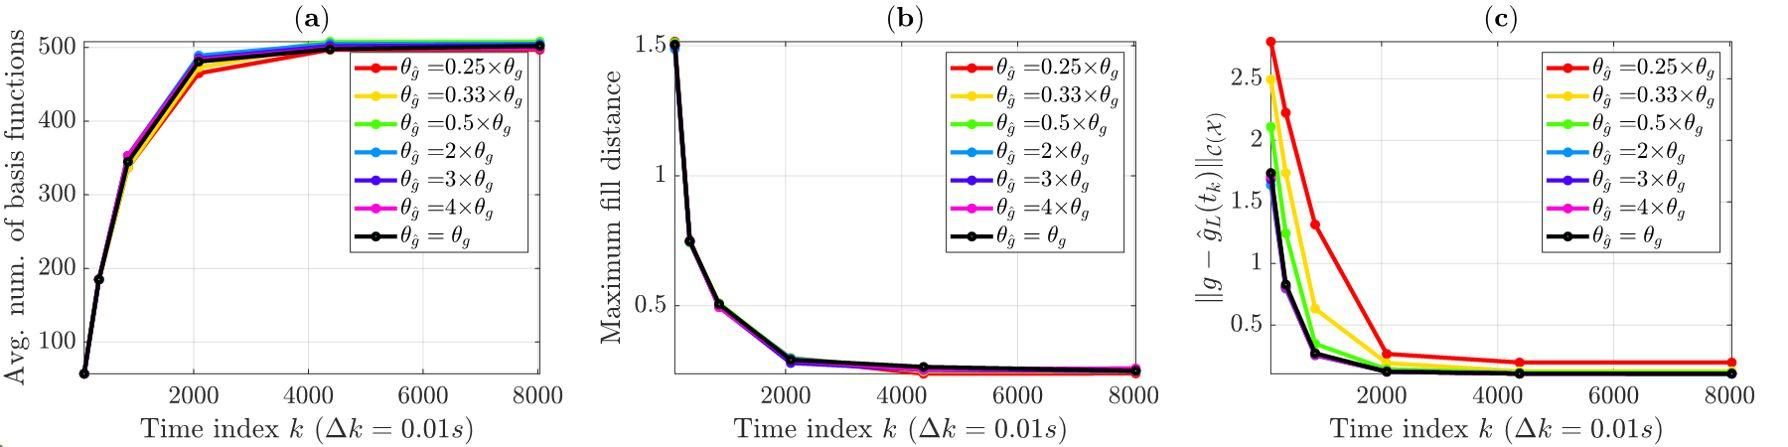How do different settings of \u03b8_j influence the behavior shown in figure (b)? From figure (b), it's apparent that various settings of 	heta_j influence the initial rate at which the maximum fill distance decreases, but all converge to a similar minimum value over time. This suggests that while the initial adjustment speed can vary, the system stabilizes consistently regardless of 	heta_j settings. 